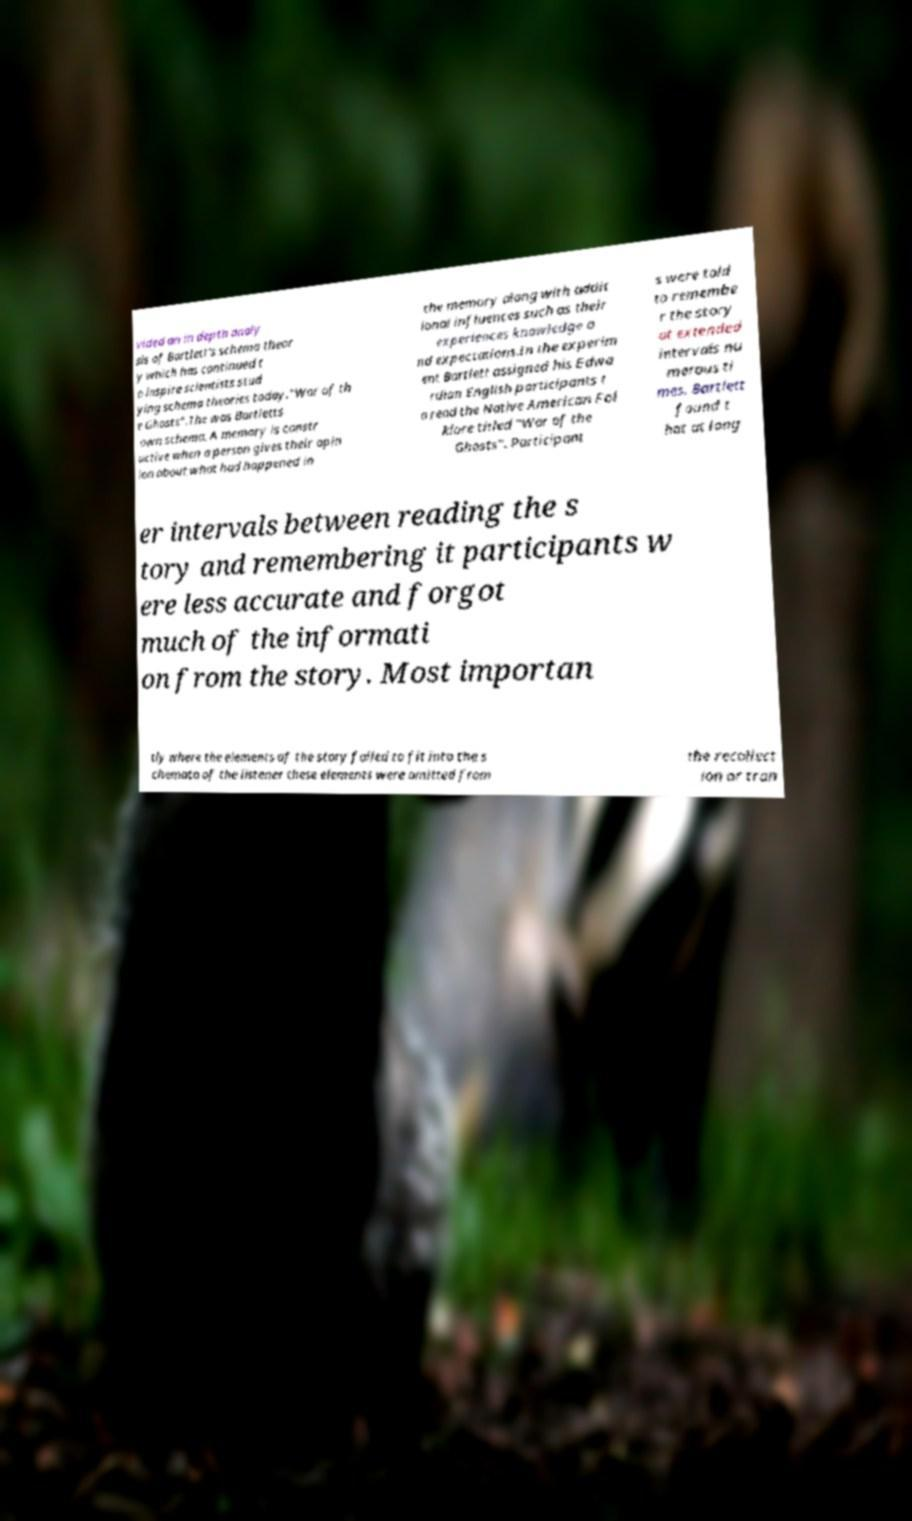Could you assist in decoding the text presented in this image and type it out clearly? vided an in depth analy sis of Bartlett's schema theor y which has continued t o inspire scientists stud ying schema theories today."War of th e Ghosts".The was Bartletts own schema. A memory is constr uctive when a person gives their opin ion about what had happened in the memory along with addit ional influences such as their experiences knowledge a nd expectations.In the experim ent Bartlett assigned his Edwa rdian English participants t o read the Native American Fol klore titled "War of the Ghosts". Participant s were told to remembe r the story at extended intervals nu merous ti mes. Bartlett found t hat at long er intervals between reading the s tory and remembering it participants w ere less accurate and forgot much of the informati on from the story. Most importan tly where the elements of the story failed to fit into the s chemata of the listener these elements were omitted from the recollect ion or tran 